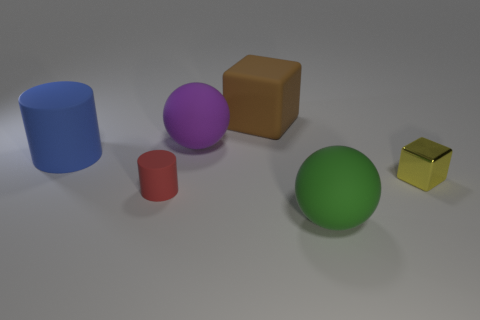How many objects in the image are reflective? The image showcases two objects with reflective properties: the purple sphere and the small shiny yellow cube. Can you tell me about their placement in relation to each other? Certainly! The shiny yellow cube is positioned to the far right and slightly in front of the purple sphere which lays toward the center but further back in the image. 